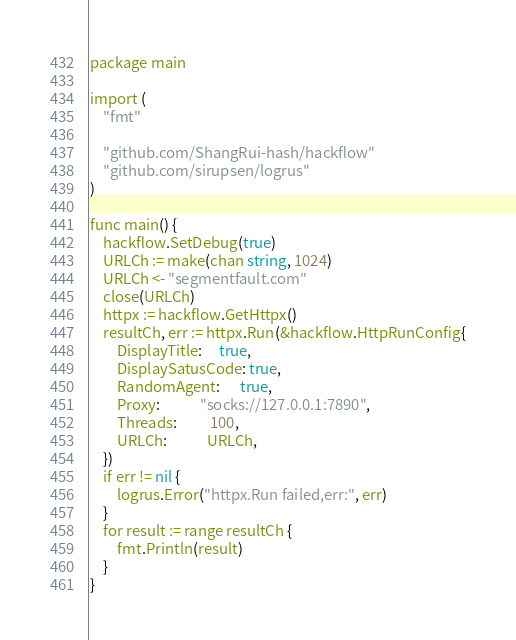<code> <loc_0><loc_0><loc_500><loc_500><_Go_>package main

import (
	"fmt"

	"github.com/ShangRui-hash/hackflow"
	"github.com/sirupsen/logrus"
)

func main() {
	hackflow.SetDebug(true)
	URLCh := make(chan string, 1024)
	URLCh <- "segmentfault.com"
	close(URLCh)
	httpx := hackflow.GetHttpx()
	resultCh, err := httpx.Run(&hackflow.HttpRunConfig{
		DisplayTitle:     true,
		DisplaySatusCode: true,
		RandomAgent:      true,
		Proxy:            "socks://127.0.0.1:7890",
		Threads:          100,
		URLCh:            URLCh,
	})
	if err != nil {
		logrus.Error("httpx.Run failed,err:", err)
	}
	for result := range resultCh {
		fmt.Println(result)
	}
}
</code> 